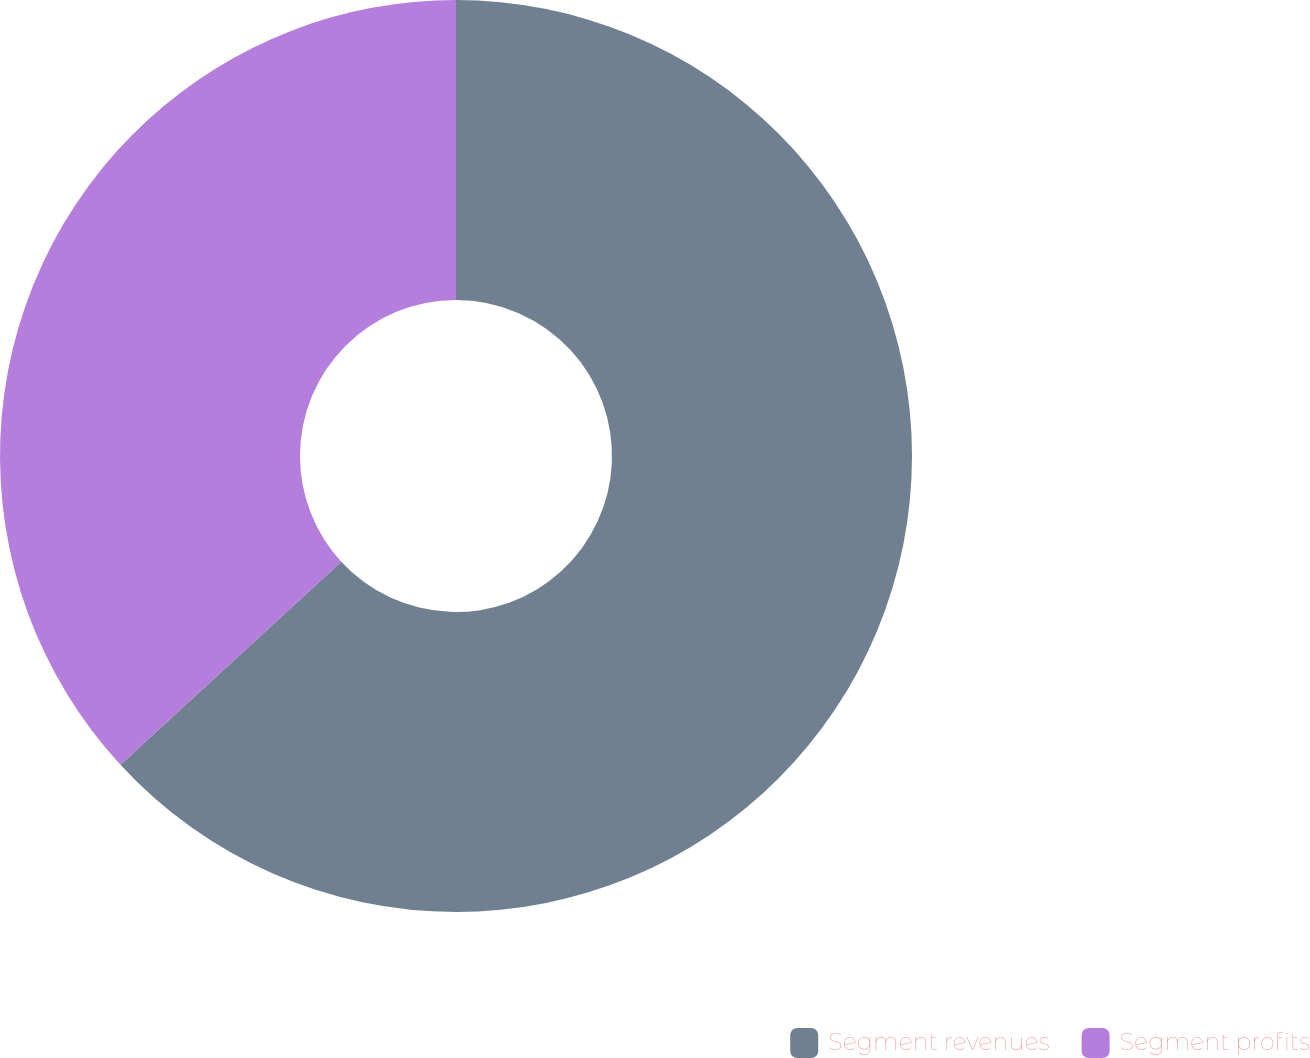Convert chart. <chart><loc_0><loc_0><loc_500><loc_500><pie_chart><fcel>Segment revenues<fcel>Segment profits<nl><fcel>63.16%<fcel>36.84%<nl></chart> 